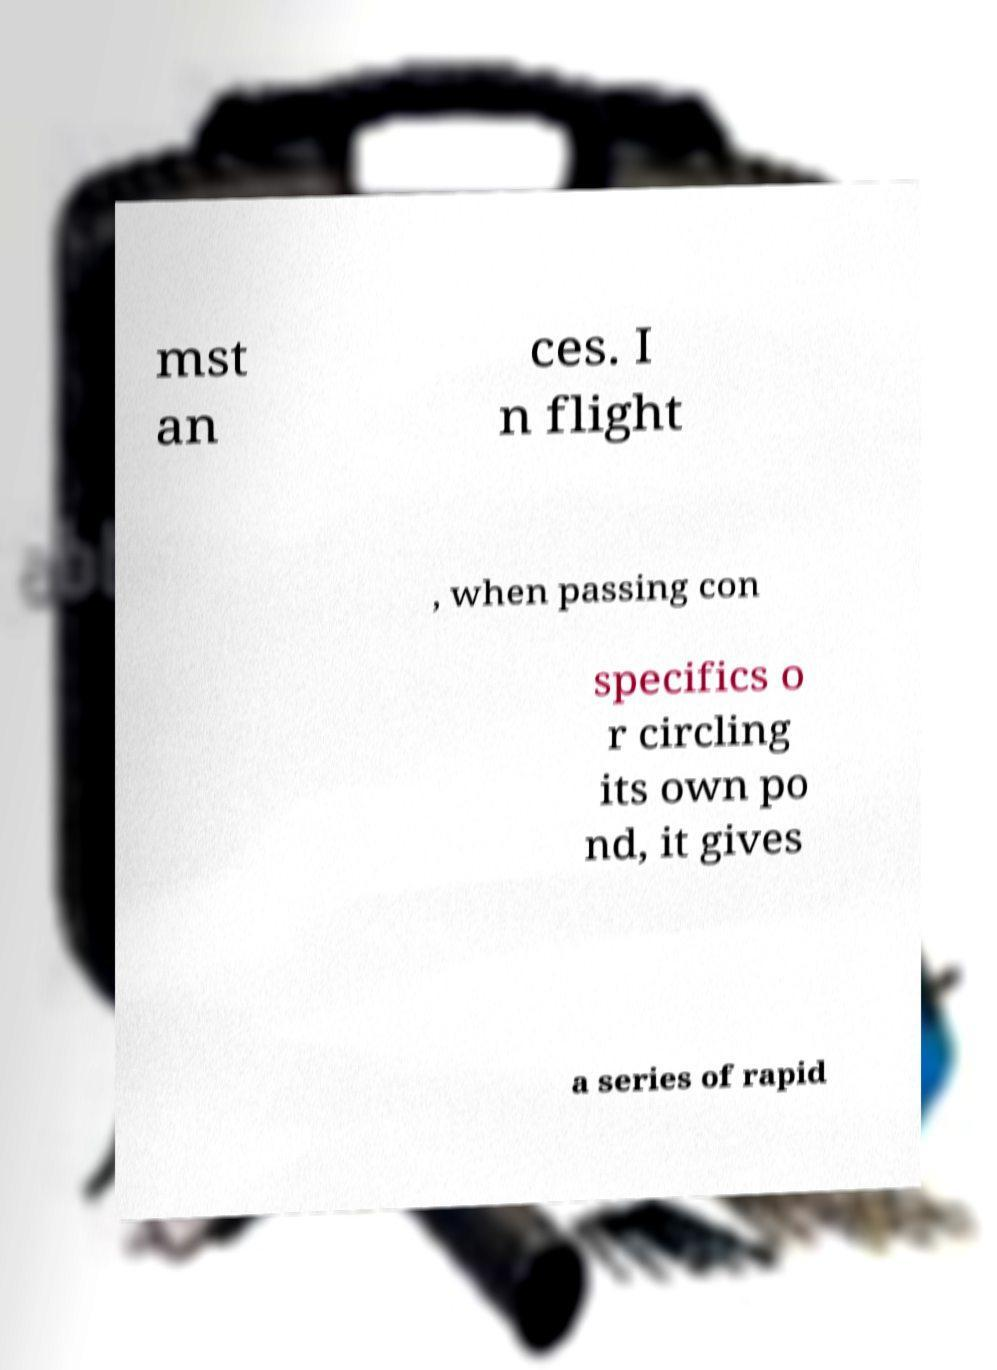Please identify and transcribe the text found in this image. mst an ces. I n flight , when passing con specifics o r circling its own po nd, it gives a series of rapid 